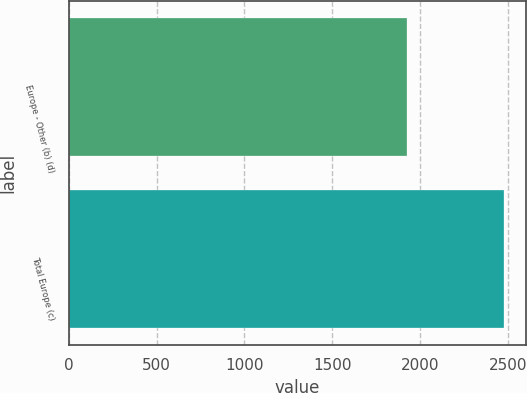Convert chart to OTSL. <chart><loc_0><loc_0><loc_500><loc_500><bar_chart><fcel>Europe - Other (b) (d)<fcel>Total Europe (c)<nl><fcel>1921<fcel>2477<nl></chart> 